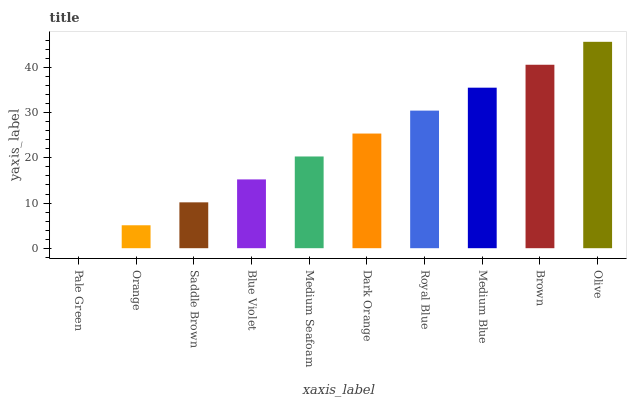Is Pale Green the minimum?
Answer yes or no. Yes. Is Olive the maximum?
Answer yes or no. Yes. Is Orange the minimum?
Answer yes or no. No. Is Orange the maximum?
Answer yes or no. No. Is Orange greater than Pale Green?
Answer yes or no. Yes. Is Pale Green less than Orange?
Answer yes or no. Yes. Is Pale Green greater than Orange?
Answer yes or no. No. Is Orange less than Pale Green?
Answer yes or no. No. Is Dark Orange the high median?
Answer yes or no. Yes. Is Medium Seafoam the low median?
Answer yes or no. Yes. Is Orange the high median?
Answer yes or no. No. Is Medium Blue the low median?
Answer yes or no. No. 